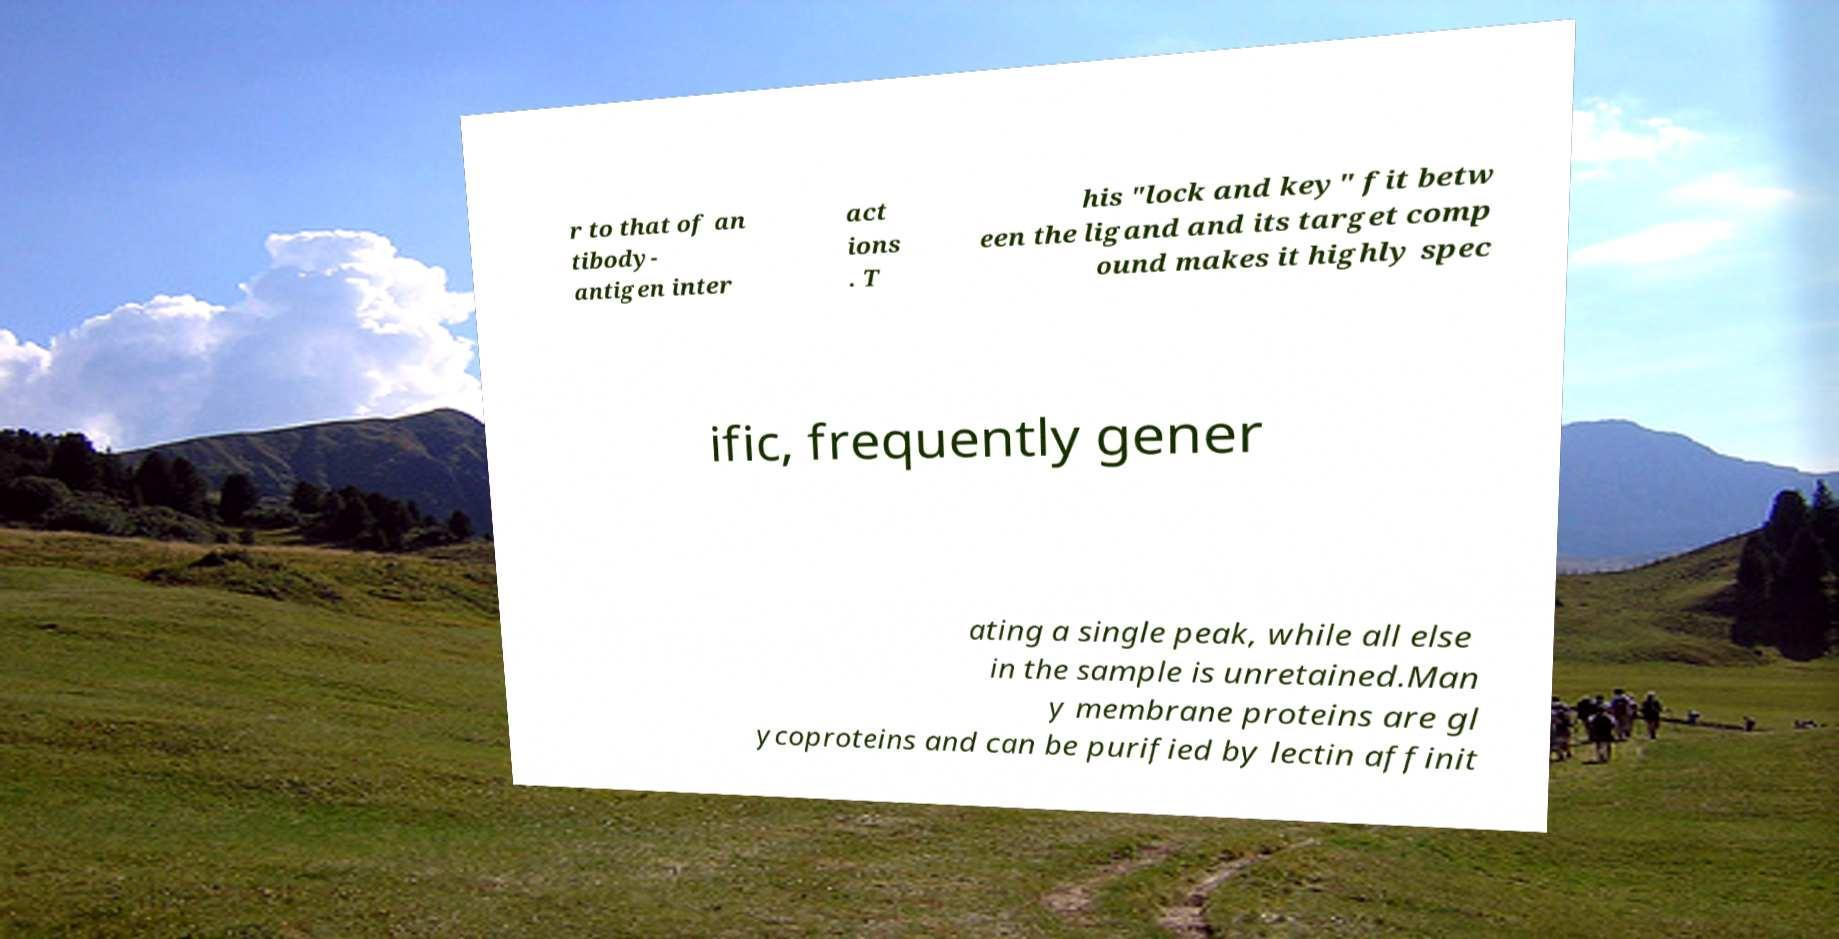There's text embedded in this image that I need extracted. Can you transcribe it verbatim? r to that of an tibody- antigen inter act ions . T his "lock and key" fit betw een the ligand and its target comp ound makes it highly spec ific, frequently gener ating a single peak, while all else in the sample is unretained.Man y membrane proteins are gl ycoproteins and can be purified by lectin affinit 